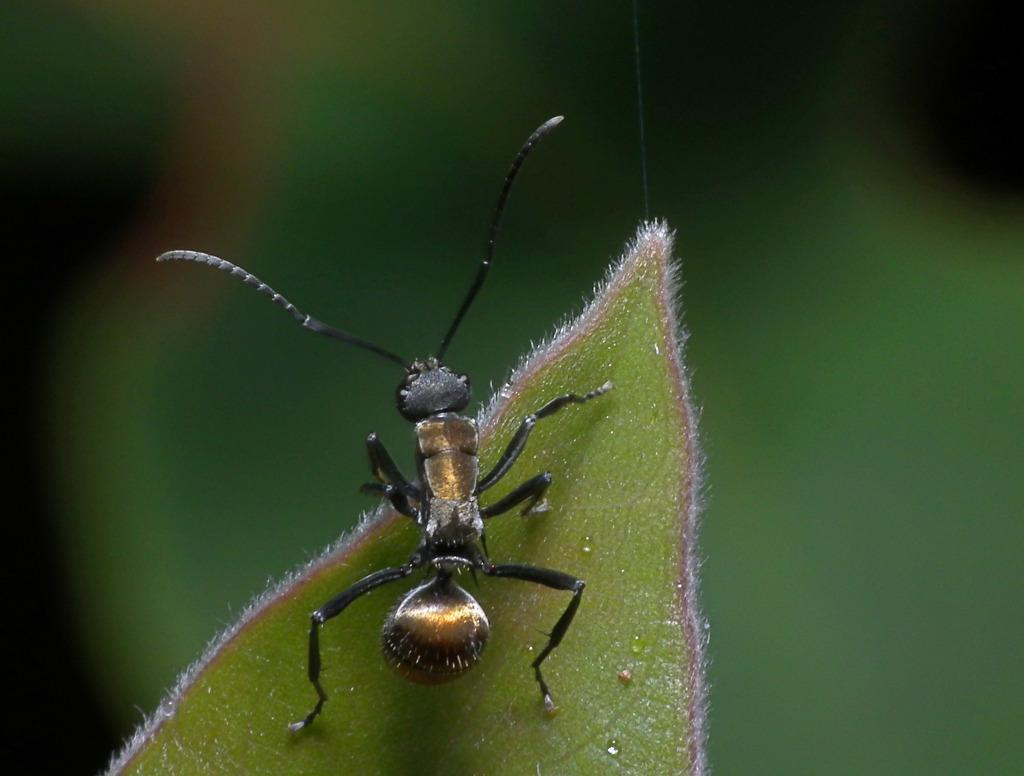What type of creature is present in the image? There is an insect in the image. Where is the insect located? The insect is on a leaf. Can you describe the background of the image? The background of the image is blurry. What type of quiet good-bye can be seen happening on the railway in the image? There is no railway or good-bye present in the image; it features an insect on a leaf with a blurry background. 